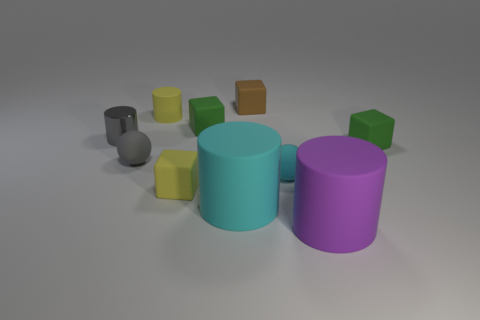There is a thing that is the same color as the shiny cylinder; what is its shape?
Ensure brevity in your answer.  Sphere. Is there anything else of the same color as the tiny metal cylinder?
Keep it short and to the point. Yes. Do the block that is to the right of the big purple rubber cylinder and the gray sphere have the same material?
Offer a very short reply. Yes. Is the number of blocks that are on the left side of the purple rubber thing greater than the number of green matte blocks that are to the right of the tiny brown cube?
Provide a succinct answer. Yes. There is another cylinder that is the same size as the shiny cylinder; what color is it?
Make the answer very short. Yellow. Are there any things of the same color as the shiny cylinder?
Your answer should be very brief. Yes. There is a small rubber sphere that is to the left of the small brown block; is its color the same as the tiny cylinder left of the small gray sphere?
Your response must be concise. Yes. There is a gray cylinder to the left of the brown rubber block; what is it made of?
Keep it short and to the point. Metal. What is the color of the small cylinder that is the same material as the brown thing?
Your answer should be very brief. Yellow. How many gray matte things have the same size as the metal cylinder?
Your response must be concise. 1. 